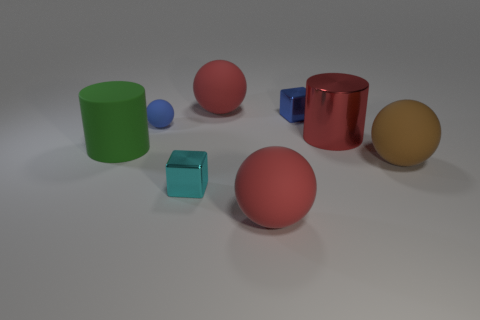Subtract all large balls. How many balls are left? 1 Subtract all red blocks. How many red spheres are left? 2 Subtract 1 balls. How many balls are left? 3 Add 1 green rubber objects. How many objects exist? 9 Subtract all blue spheres. How many spheres are left? 3 Subtract all green spheres. Subtract all gray cubes. How many spheres are left? 4 Subtract 1 cyan cubes. How many objects are left? 7 Subtract all cylinders. How many objects are left? 6 Subtract all small blue blocks. Subtract all large red matte objects. How many objects are left? 5 Add 7 large red matte objects. How many large red matte objects are left? 9 